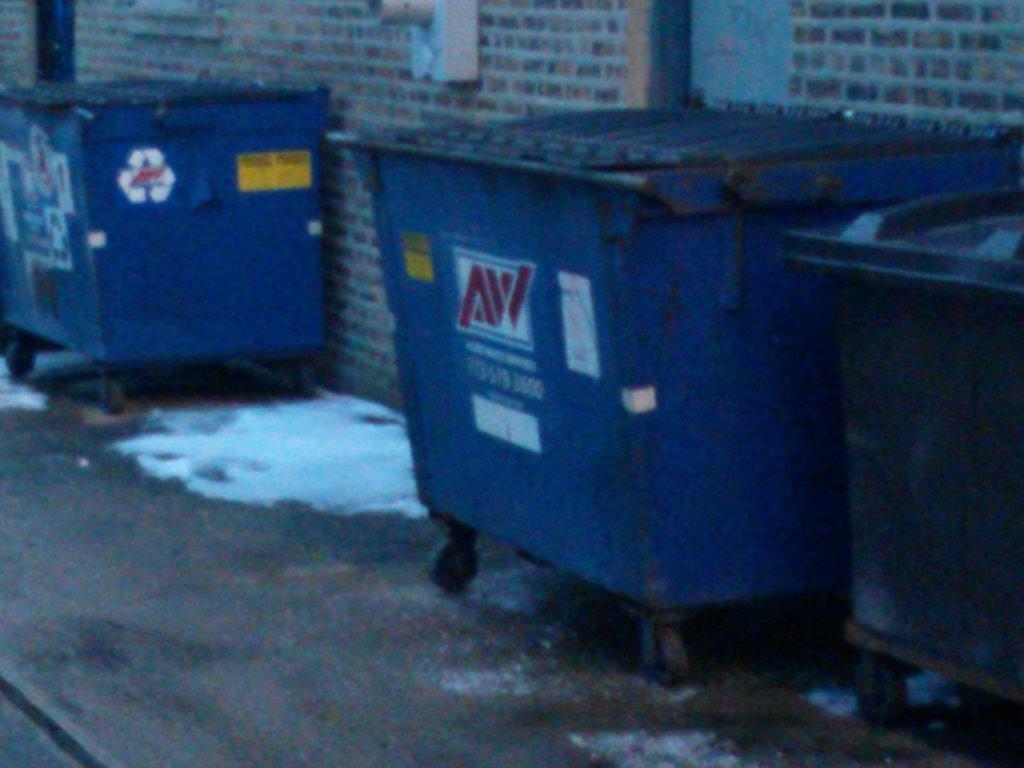What type of trash bins are in the image? The trash bins in the image have wheels. What can be seen in the background of the image? There is a brick wall in the background of the image. What is the name of the person hosting the party in the image? There is no party or person mentioned in the image; it only features trash bins with wheels and a brick wall in the background. 